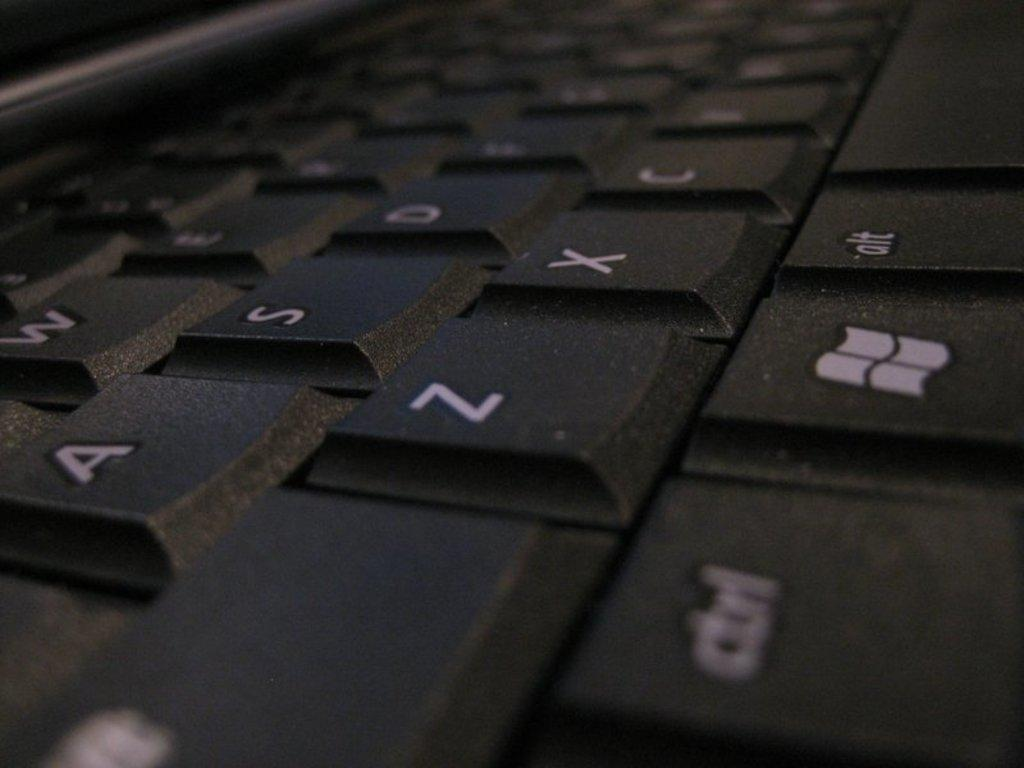Provide a one-sentence caption for the provided image. a close up of a black key board with letters A, Z, and X. 